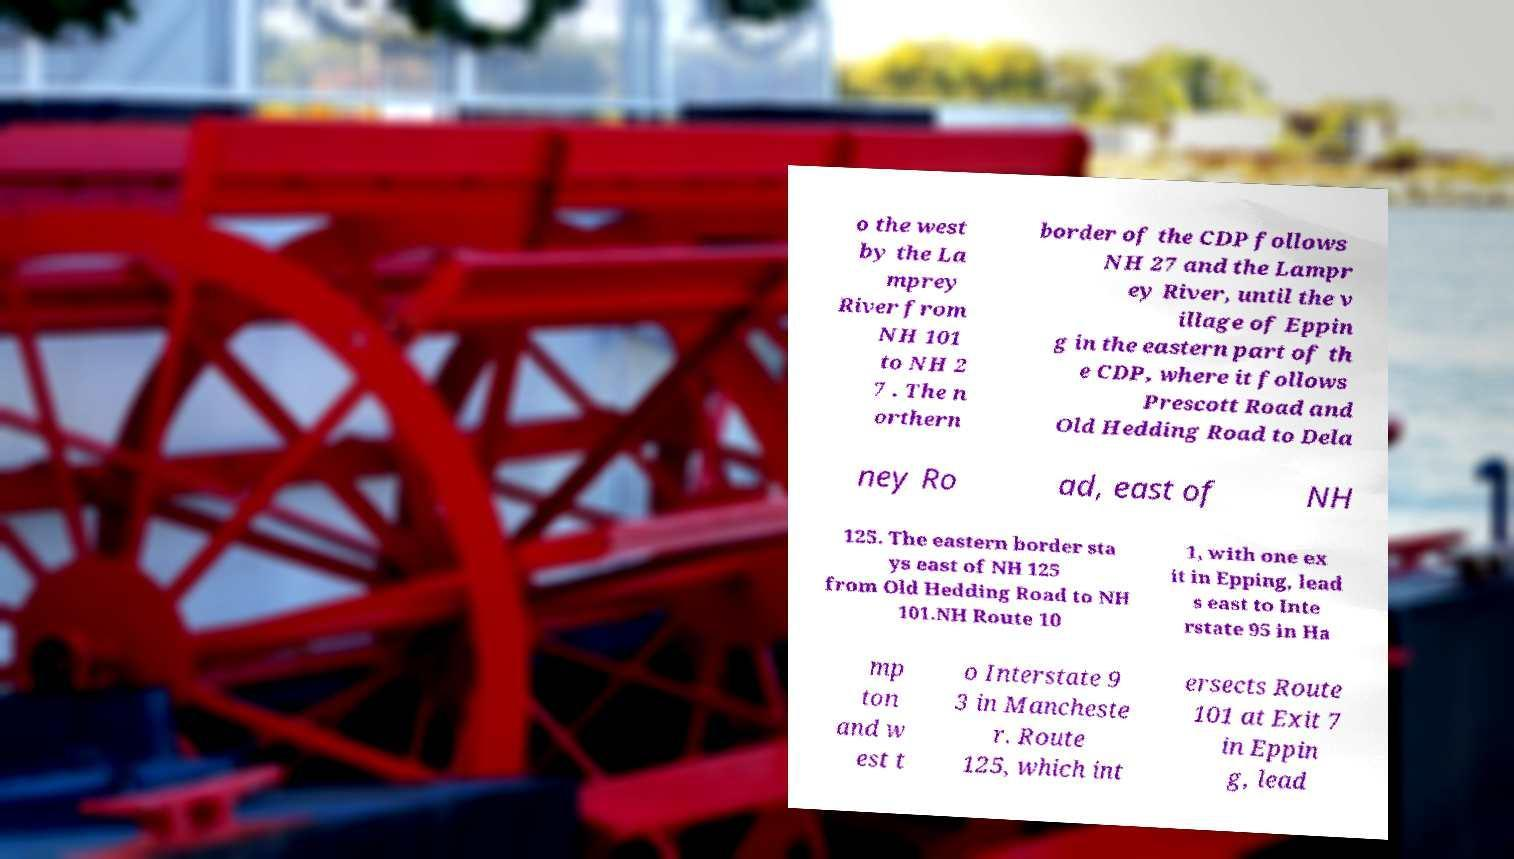There's text embedded in this image that I need extracted. Can you transcribe it verbatim? o the west by the La mprey River from NH 101 to NH 2 7 . The n orthern border of the CDP follows NH 27 and the Lampr ey River, until the v illage of Eppin g in the eastern part of th e CDP, where it follows Prescott Road and Old Hedding Road to Dela ney Ro ad, east of NH 125. The eastern border sta ys east of NH 125 from Old Hedding Road to NH 101.NH Route 10 1, with one ex it in Epping, lead s east to Inte rstate 95 in Ha mp ton and w est t o Interstate 9 3 in Mancheste r. Route 125, which int ersects Route 101 at Exit 7 in Eppin g, lead 